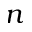Convert formula to latex. <formula><loc_0><loc_0><loc_500><loc_500>n</formula> 